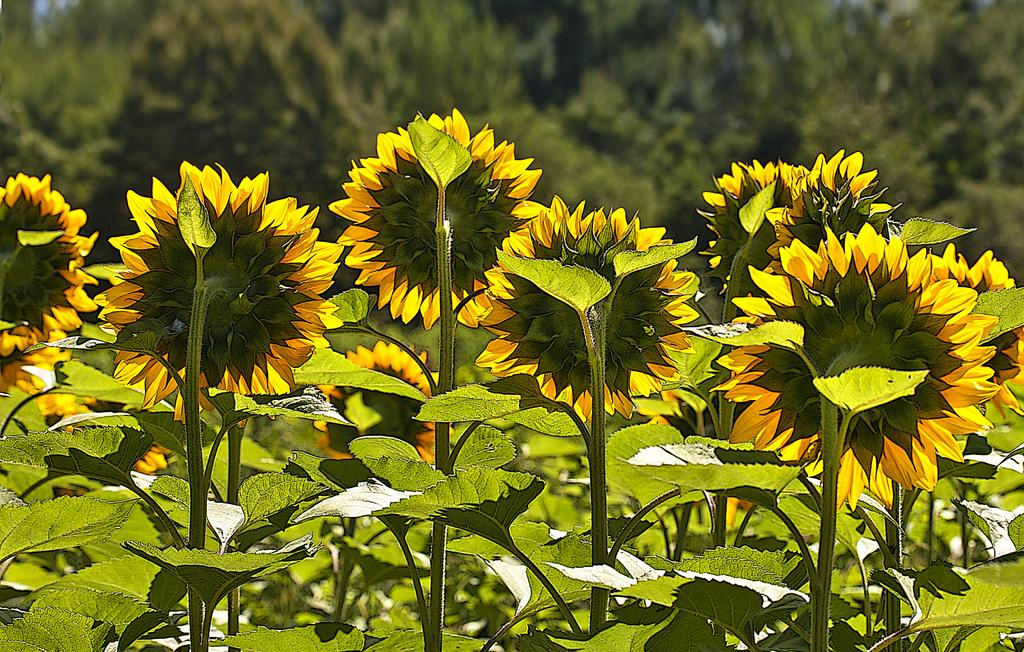What types of vegetation can be seen in the image? There are many plants in the image, including some with sunflowers. What direction are the sunflowers facing? The sunflowers are turned towards the back side. What other types of vegetation are visible in the image? There are many trees visible in the image. What type of mine can be seen in the image? There is no mine present in the image; it features plants and trees. Can you see an uncle holding a sunflower in the image? There is no person, including an uncle, present in the image. 